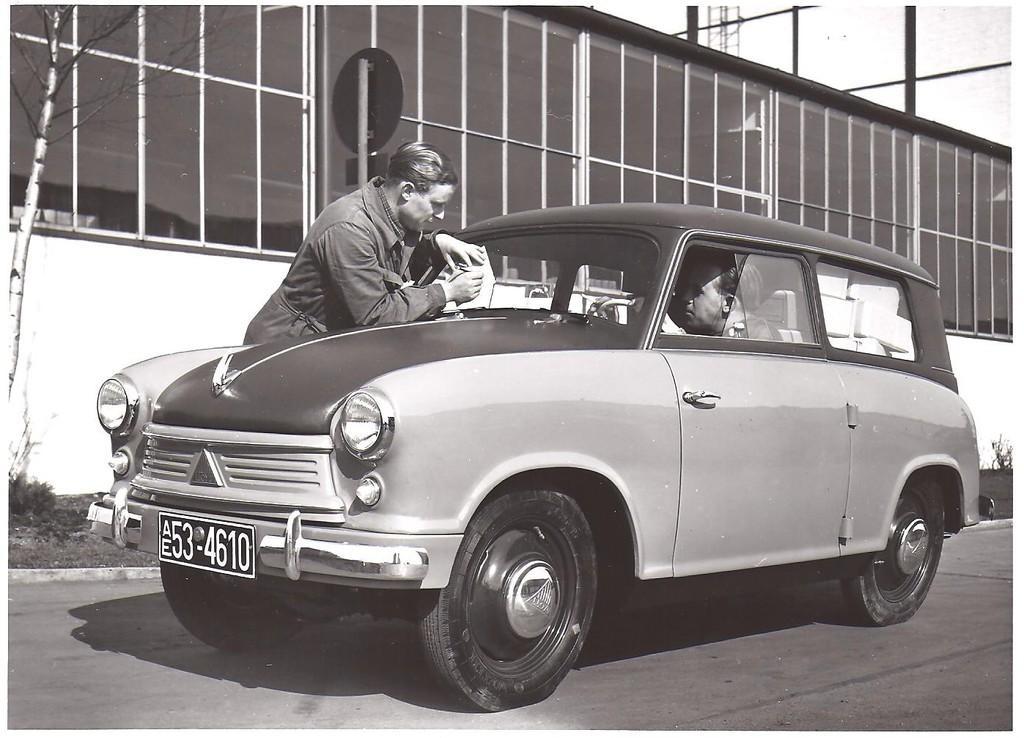Describe this image in one or two sentences. There are people in the image, one is sitting in the car and another man is standing at the car an writing. At the back of the man there is a building, there is a tree beside the man and there is a sky at the top of the image 